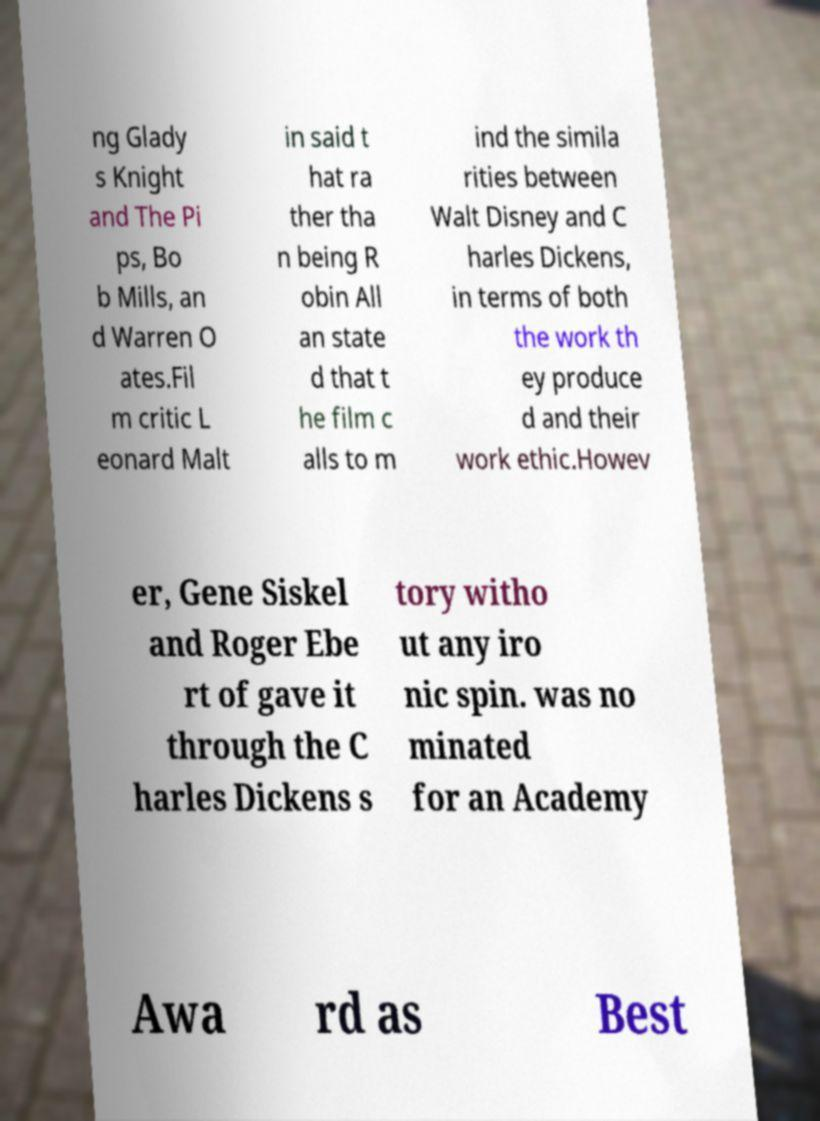Could you assist in decoding the text presented in this image and type it out clearly? ng Glady s Knight and The Pi ps, Bo b Mills, an d Warren O ates.Fil m critic L eonard Malt in said t hat ra ther tha n being R obin All an state d that t he film c alls to m ind the simila rities between Walt Disney and C harles Dickens, in terms of both the work th ey produce d and their work ethic.Howev er, Gene Siskel and Roger Ebe rt of gave it through the C harles Dickens s tory witho ut any iro nic spin. was no minated for an Academy Awa rd as Best 